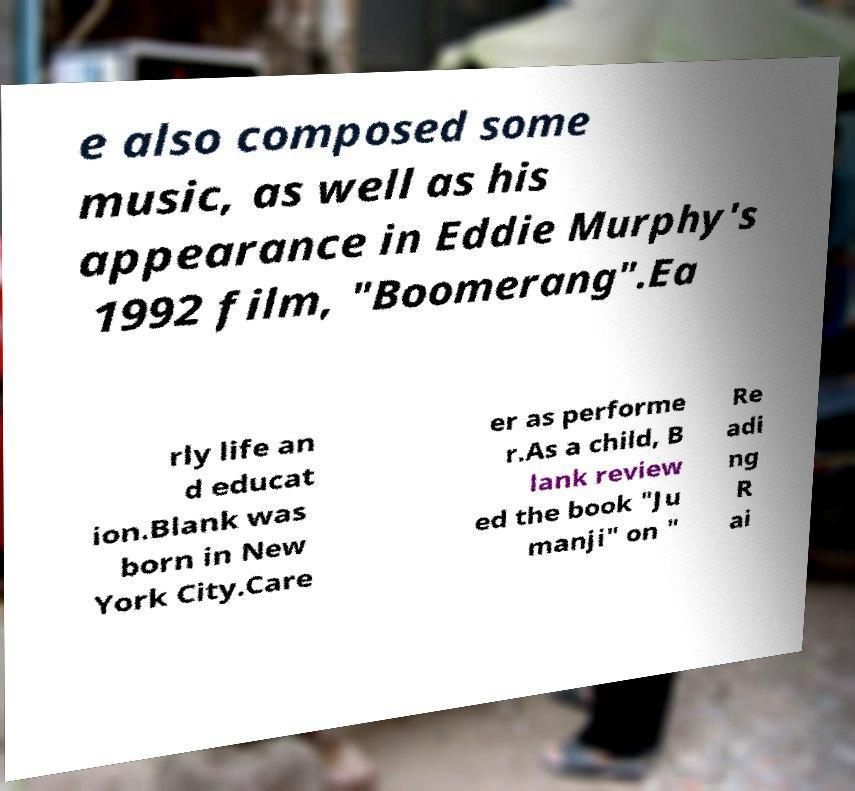Could you extract and type out the text from this image? e also composed some music, as well as his appearance in Eddie Murphy's 1992 film, "Boomerang".Ea rly life an d educat ion.Blank was born in New York City.Care er as performe r.As a child, B lank review ed the book "Ju manji" on " Re adi ng R ai 